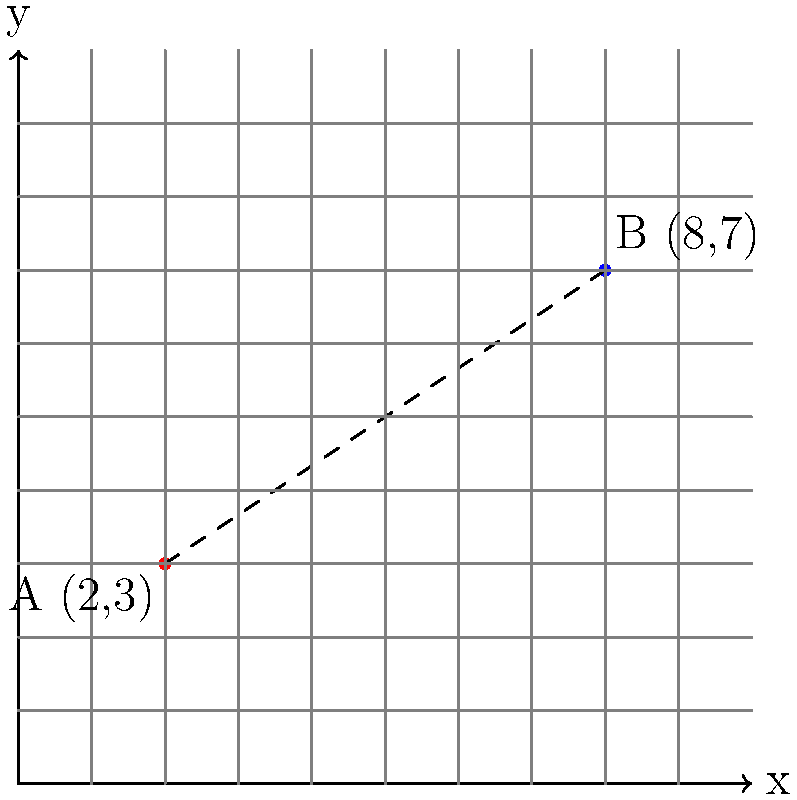You've discovered two prime fishing spots in the Beira Lake, Colombo. Spot A is located at coordinates (2,3) and Spot B is at (8,7) on your fishing map. What is the distance between these two fishing spots? To find the distance between two points on a coordinate plane, we can use the distance formula, which is derived from the Pythagorean theorem:

Distance = $\sqrt{(x_2-x_1)^2 + (y_2-y_1)^2}$

Where $(x_1,y_1)$ are the coordinates of the first point and $(x_2,y_2)$ are the coordinates of the second point.

Let's solve this step-by-step:

1) Identify the coordinates:
   Spot A: $(x_1,y_1) = (2,3)$
   Spot B: $(x_2,y_2) = (8,7)$

2) Plug these into the distance formula:
   Distance = $\sqrt{(8-2)^2 + (7-3)^2}$

3) Simplify inside the parentheses:
   Distance = $\sqrt{6^2 + 4^2}$

4) Calculate the squares:
   Distance = $\sqrt{36 + 16}$

5) Add inside the square root:
   Distance = $\sqrt{52}$

6) Simplify the square root:
   Distance = $2\sqrt{13}$

Therefore, the distance between the two fishing spots is $2\sqrt{13}$ units on your map.
Answer: $2\sqrt{13}$ units 